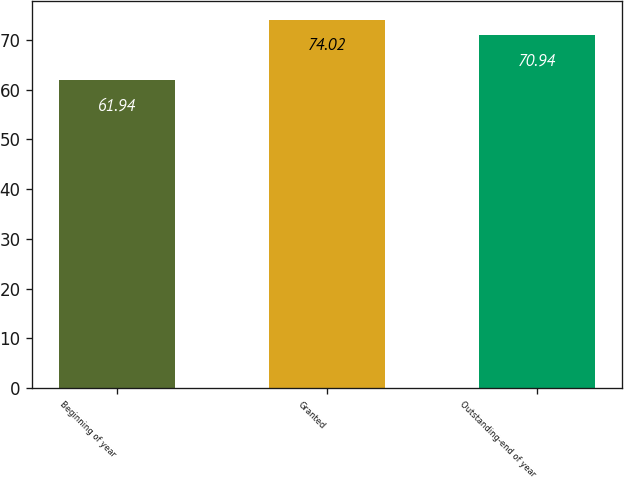Convert chart. <chart><loc_0><loc_0><loc_500><loc_500><bar_chart><fcel>Beginning of year<fcel>Granted<fcel>Outstanding-end of year<nl><fcel>61.94<fcel>74.02<fcel>70.94<nl></chart> 